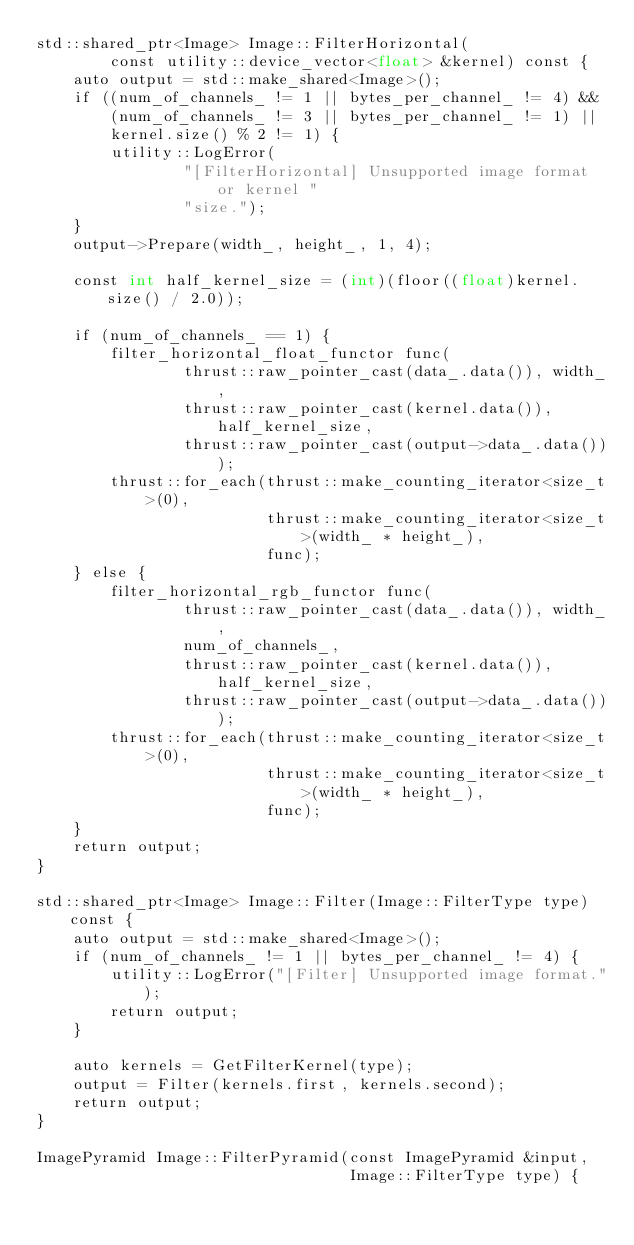<code> <loc_0><loc_0><loc_500><loc_500><_Cuda_>std::shared_ptr<Image> Image::FilterHorizontal(
        const utility::device_vector<float> &kernel) const {
    auto output = std::make_shared<Image>();
    if ((num_of_channels_ != 1 || bytes_per_channel_ != 4) &&
        (num_of_channels_ != 3 || bytes_per_channel_ != 1) ||
        kernel.size() % 2 != 1) {
        utility::LogError(
                "[FilterHorizontal] Unsupported image format or kernel "
                "size.");
    }
    output->Prepare(width_, height_, 1, 4);

    const int half_kernel_size = (int)(floor((float)kernel.size() / 2.0));

    if (num_of_channels_ == 1) {
        filter_horizontal_float_functor func(
                thrust::raw_pointer_cast(data_.data()), width_,
                thrust::raw_pointer_cast(kernel.data()), half_kernel_size,
                thrust::raw_pointer_cast(output->data_.data()));
        thrust::for_each(thrust::make_counting_iterator<size_t>(0),
                         thrust::make_counting_iterator<size_t>(width_ * height_),
                         func);
    } else {
        filter_horizontal_rgb_functor func(
                thrust::raw_pointer_cast(data_.data()), width_,
                num_of_channels_,
                thrust::raw_pointer_cast(kernel.data()), half_kernel_size,
                thrust::raw_pointer_cast(output->data_.data()));
        thrust::for_each(thrust::make_counting_iterator<size_t>(0),
                         thrust::make_counting_iterator<size_t>(width_ * height_),
                         func);
    }
    return output;
}

std::shared_ptr<Image> Image::Filter(Image::FilterType type) const {
    auto output = std::make_shared<Image>();
    if (num_of_channels_ != 1 || bytes_per_channel_ != 4) {
        utility::LogError("[Filter] Unsupported image format.");
        return output;
    }

    auto kernels = GetFilterKernel(type);
    output = Filter(kernels.first, kernels.second);
    return output;
}

ImagePyramid Image::FilterPyramid(const ImagePyramid &input,
                                  Image::FilterType type) {</code> 